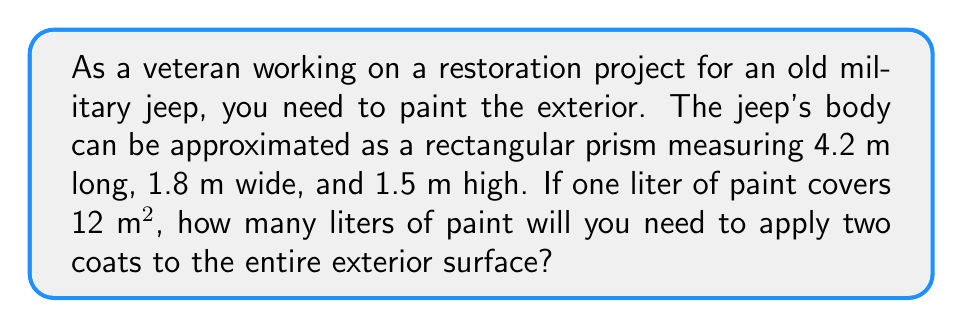Give your solution to this math problem. Let's approach this step-by-step:

1) First, we need to calculate the surface area of the jeep:
   
   Surface area = 2(length × width + length × height + width × height)
   
   $$ SA = 2(4.2 \times 1.8 + 4.2 \times 1.5 + 1.8 \times 1.5) $$

2) Let's calculate each part:
   
   $4.2 \times 1.8 = 7.56$
   $4.2 \times 1.5 = 6.3$
   $1.8 \times 1.5 = 2.7$

3) Now, let's sum these up and multiply by 2:
   
   $$ SA = 2(7.56 + 6.3 + 2.7) = 2(16.56) = 33.12 \text{ m}^2 $$

4) We need to apply two coats, so we double this area:
   
   $$ \text{Total area to paint} = 33.12 \times 2 = 66.24 \text{ m}^2 $$

5) We know that 1 liter covers 12 m². To find how many liters we need, we divide the total area by the area one liter covers:
   
   $$ \text{Liters of paint} = \frac{66.24 \text{ m}^2}{12 \text{ m}^2/\text{L}} = 5.52 \text{ L} $$

6) Rounding up to ensure we have enough paint:
   
   We need 5.52 L, so we'll round up to 6 L to be safe.
Answer: 6 L 